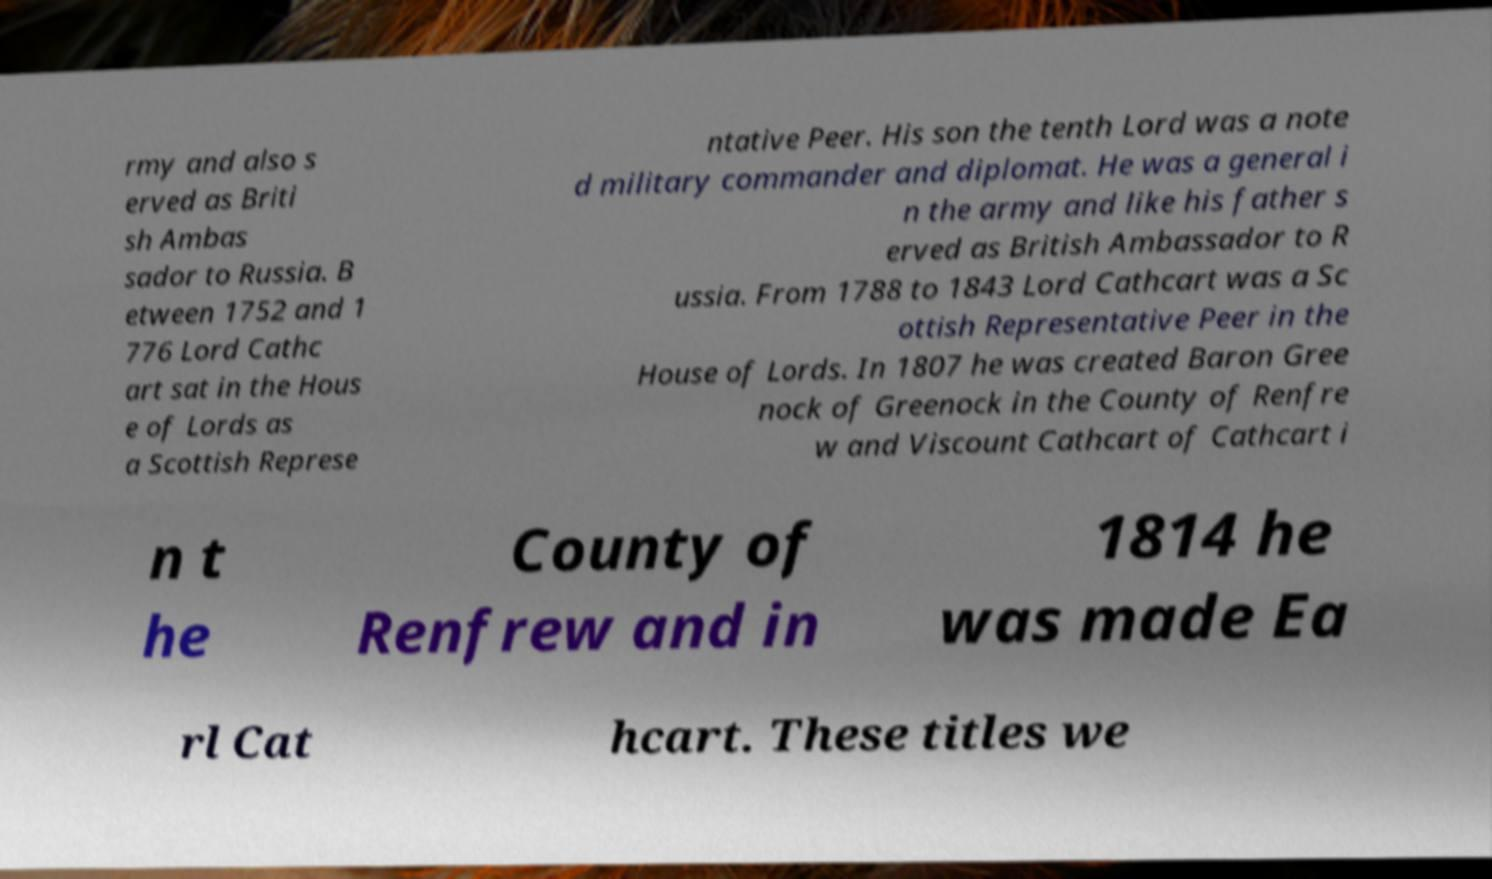Could you extract and type out the text from this image? rmy and also s erved as Briti sh Ambas sador to Russia. B etween 1752 and 1 776 Lord Cathc art sat in the Hous e of Lords as a Scottish Represe ntative Peer. His son the tenth Lord was a note d military commander and diplomat. He was a general i n the army and like his father s erved as British Ambassador to R ussia. From 1788 to 1843 Lord Cathcart was a Sc ottish Representative Peer in the House of Lords. In 1807 he was created Baron Gree nock of Greenock in the County of Renfre w and Viscount Cathcart of Cathcart i n t he County of Renfrew and in 1814 he was made Ea rl Cat hcart. These titles we 